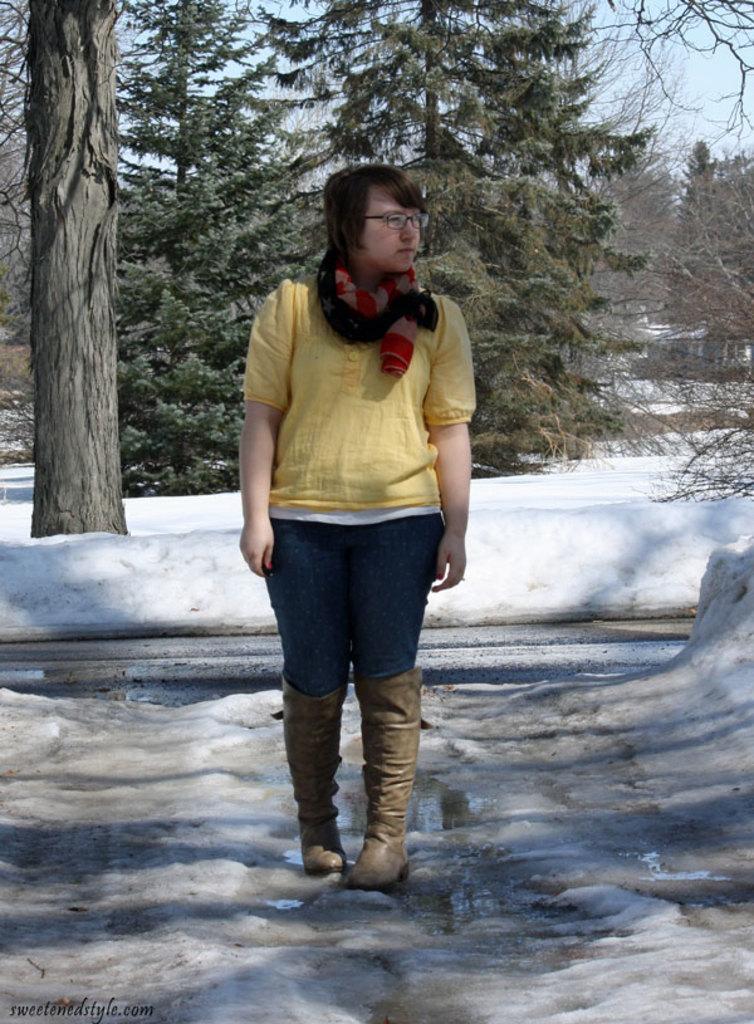Describe this image in one or two sentences. In this image we can see woman standing on the snow. In the background we can see sky, trees and snow. 